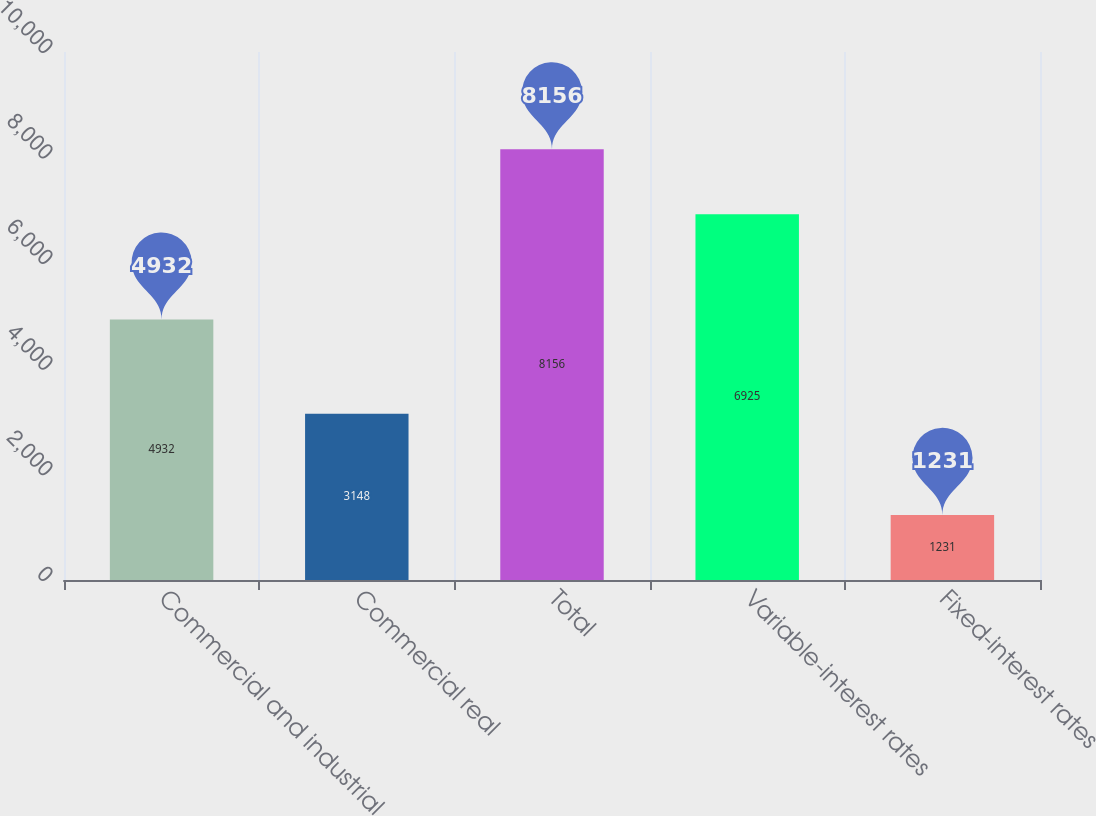<chart> <loc_0><loc_0><loc_500><loc_500><bar_chart><fcel>Commercial and industrial<fcel>Commercial real<fcel>Total<fcel>Variable-interest rates<fcel>Fixed-interest rates<nl><fcel>4932<fcel>3148<fcel>8156<fcel>6925<fcel>1231<nl></chart> 